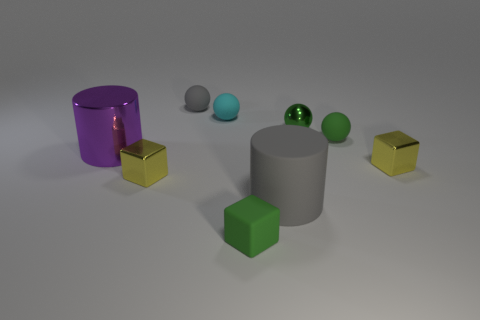The cyan thing that is the same material as the small gray sphere is what shape?
Ensure brevity in your answer.  Sphere. Are the gray object behind the big purple thing and the gray cylinder made of the same material?
Provide a succinct answer. Yes. What shape is the small thing that is the same color as the large matte thing?
Keep it short and to the point. Sphere. There is a rubber ball that is right of the metal ball; is it the same color as the matte sphere that is on the left side of the small cyan matte sphere?
Your answer should be compact. No. How many cylinders are on the left side of the gray ball and right of the small gray rubber ball?
Offer a very short reply. 0. What is the tiny gray object made of?
Offer a terse response. Rubber. There is a purple metal thing that is the same size as the gray cylinder; what is its shape?
Offer a terse response. Cylinder. Do the cylinder in front of the purple cylinder and the gray object that is behind the green metallic object have the same material?
Keep it short and to the point. Yes. What number of yellow blocks are there?
Offer a very short reply. 2. How many large purple shiny objects have the same shape as the small cyan thing?
Your response must be concise. 0. 